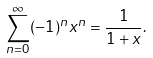<formula> <loc_0><loc_0><loc_500><loc_500>\sum _ { n = 0 } ^ { \infty } ( - 1 ) ^ { n } x ^ { n } = { \frac { 1 } { 1 + x } } .</formula> 